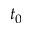<formula> <loc_0><loc_0><loc_500><loc_500>t _ { 0 }</formula> 